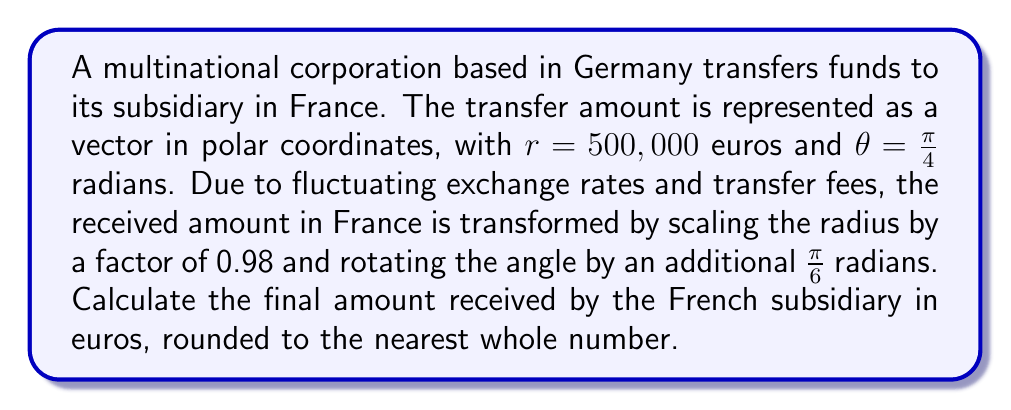Teach me how to tackle this problem. To solve this problem, we'll follow these steps:

1) First, we need to understand the initial and final transformations:
   Initial: $r_1 = 500,000$, $\theta_1 = \frac{\pi}{4}$
   Transformation: $r_2 = 0.98r_1$, $\theta_2 = \theta_1 + \frac{\pi}{6}$

2) Calculate the new radius:
   $r_2 = 0.98 \times 500,000 = 490,000$ euros

3) Calculate the new angle:
   $\theta_2 = \frac{\pi}{4} + \frac{\pi}{6} = \frac{5\pi}{12}$ radians

4) Now, we have the new polar coordinates: $(490,000, \frac{5\pi}{12})$

5) To find the final amount, we need to calculate the x-component of this vector, as it represents the real part of the complex number in the complex plane:

   $x = r_2 \cos(\theta_2)$

6) Substitute the values:
   $x = 490,000 \cos(\frac{5\pi}{12})$

7) Calculate:
   $\cos(\frac{5\pi}{12}) \approx 0.25881904510252074$

8) Multiply:
   $x = 490,000 \times 0.25881904510252074 \approx 126,821.33$

9) Round to the nearest whole number:
   $126,821$ euros
Answer: $126,821$ euros 